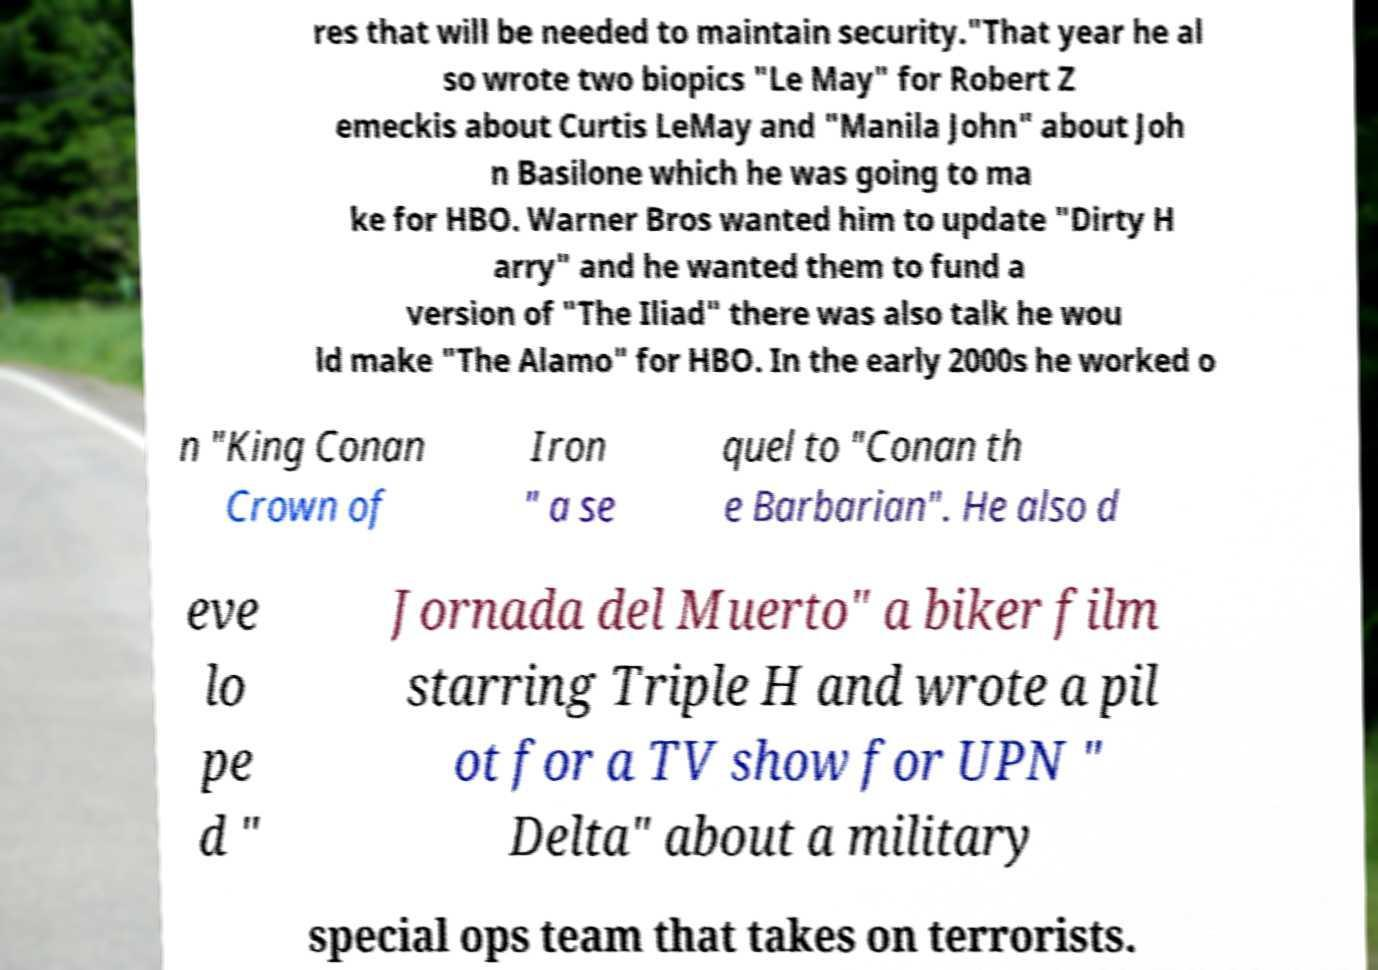Can you read and provide the text displayed in the image?This photo seems to have some interesting text. Can you extract and type it out for me? res that will be needed to maintain security."That year he al so wrote two biopics "Le May" for Robert Z emeckis about Curtis LeMay and "Manila John" about Joh n Basilone which he was going to ma ke for HBO. Warner Bros wanted him to update "Dirty H arry" and he wanted them to fund a version of "The Iliad" there was also talk he wou ld make "The Alamo" for HBO. In the early 2000s he worked o n "King Conan Crown of Iron " a se quel to "Conan th e Barbarian". He also d eve lo pe d " Jornada del Muerto" a biker film starring Triple H and wrote a pil ot for a TV show for UPN " Delta" about a military special ops team that takes on terrorists. 